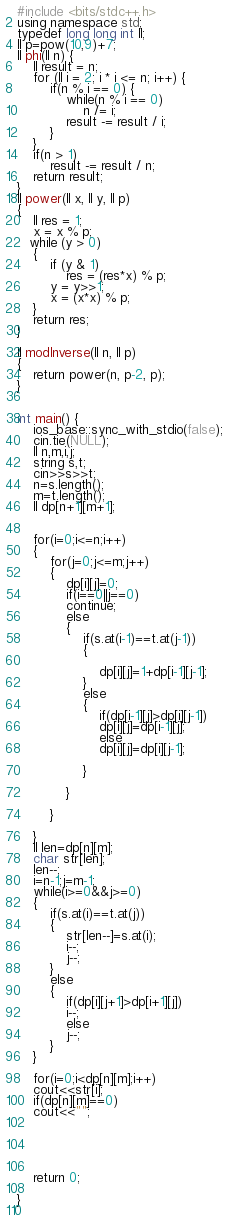<code> <loc_0><loc_0><loc_500><loc_500><_C++_>#include <bits/stdc++.h>
using namespace std;
typedef long long int ll;
ll p=pow(10,9)+7;
ll phi(ll n) {
    ll result = n;
    for (ll i = 2; i * i <= n; i++) {
        if(n % i == 0) {
            while(n % i == 0)
                n /= i;
            result -= result / i;
        }
    }
    if(n > 1)
        result -= result / n;
    return result;
}
ll power(ll x, ll y, ll p) 
{ 
    ll res = 1;      
    x = x % p;  
   while (y > 0) 
    { 
        if (y & 1) 
            res = (res*x) % p; 
        y = y>>1; 
        x = (x*x) % p; 
    } 
    return res; 
} 

ll modInverse(ll n, ll p) 
{ 
    return power(n, p-2, p); 
}


int main() {
    ios_base::sync_with_stdio(false);
    cin.tie(NULL);
    ll n,m,i,j;
    string s,t;
    cin>>s>>t;
    n=s.length();
    m=t.length();
    ll dp[n+1][m+1];

    
    for(i=0;i<=n;i++)
    {
        for(j=0;j<=m;j++)
        {
            dp[i][j]=0;
            if(i==0||j==0)
            continue;
            else
            {
                if(s.at(i-1)==t.at(j-1))
                {
                   
                    dp[i][j]=1+dp[i-1][j-1];
                }
                else
                {
                    if(dp[i-1][j]>dp[i][j-1])
                    dp[i][j]=dp[i-1][j];
                    else
                    dp[i][j]=dp[i][j-1];
                    
                }
                
            }
            
        }
        
    }
    ll len=dp[n][m];
    char str[len];
    len--;
    i=n-1;j=m-1;
    while(i>=0&&j>=0)
    {
        if(s.at(i)==t.at(j))
        {
            str[len--]=s.at(i);
            i--;
            j--;
        }
        else
        {
            if(dp[i][j+1]>dp[i+1][j])
            i--;
            else
            j--;
        }
    }
  
    for(i=0;i<dp[n][m];i++)
    cout<<str[i];
    if(dp[n][m]==0)
    cout<<"";

    
   
  
 
    return 0;
    
}
    

</code> 